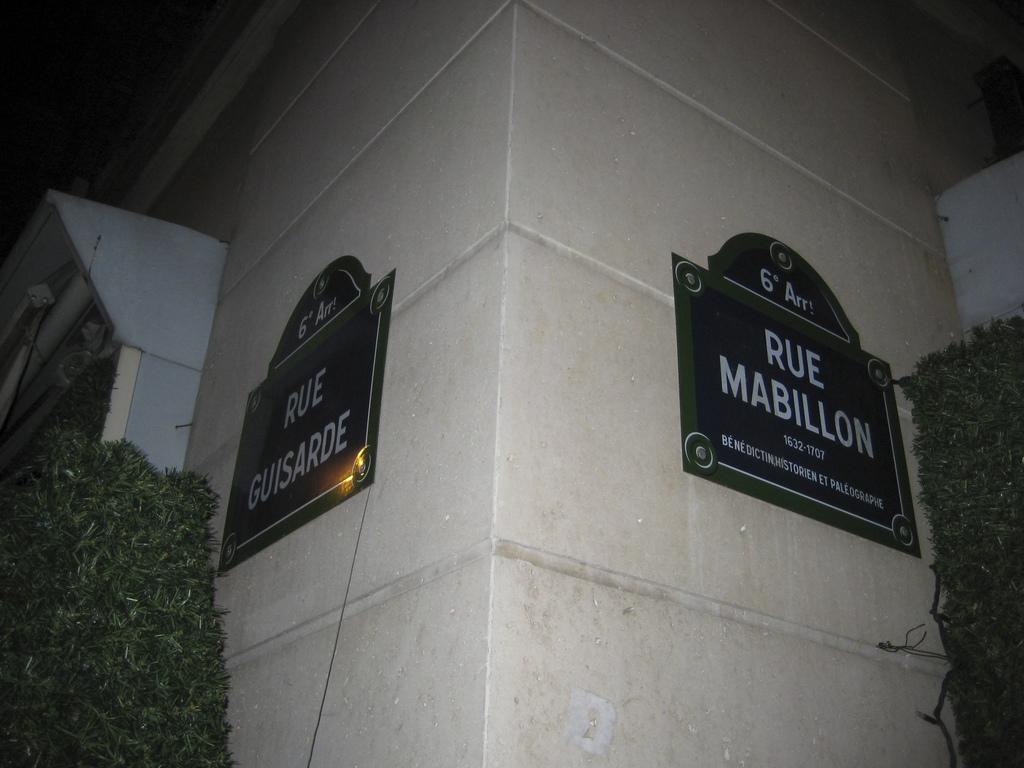What is attached to the white wall in the image? There are two boards on a white color wall in the image. What type of living organisms can be seen in the image? Plants are visible in the image. How would you describe the lighting in the image? The image is a little dark. What route does the balloon take in the image? There is no balloon present in the image, so it is not possible to determine a route. What do you believe the plants in the image represent? The purpose or meaning of the plants in the image cannot be determined from the image alone, as it is subjective and depends on individual interpretation. 